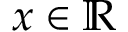<formula> <loc_0><loc_0><loc_500><loc_500>x \in \mathbb { R }</formula> 